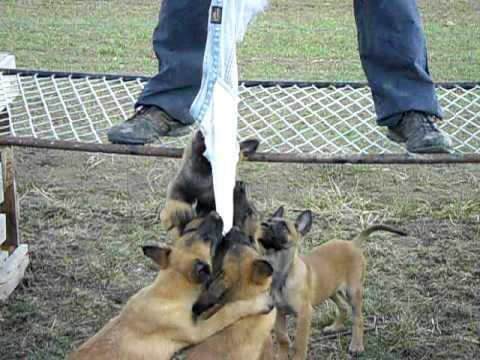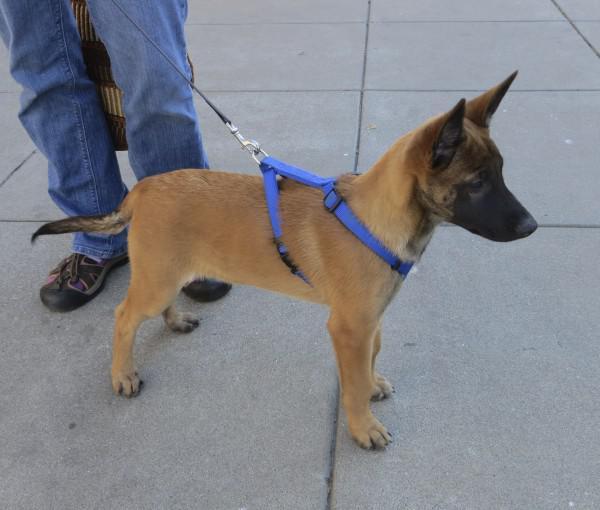The first image is the image on the left, the second image is the image on the right. Given the left and right images, does the statement "An image shows exactly one german shepherd dog, which is reclining on the grass." hold true? Answer yes or no. No. The first image is the image on the left, the second image is the image on the right. Considering the images on both sides, is "In one of the images there is a large dog laying in the grass." valid? Answer yes or no. No. 